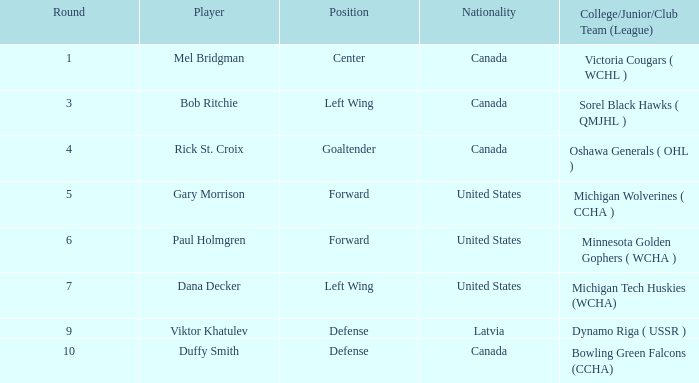What college/junior/club team (league) features 6 as the round? Minnesota Golden Gophers ( WCHA ). 